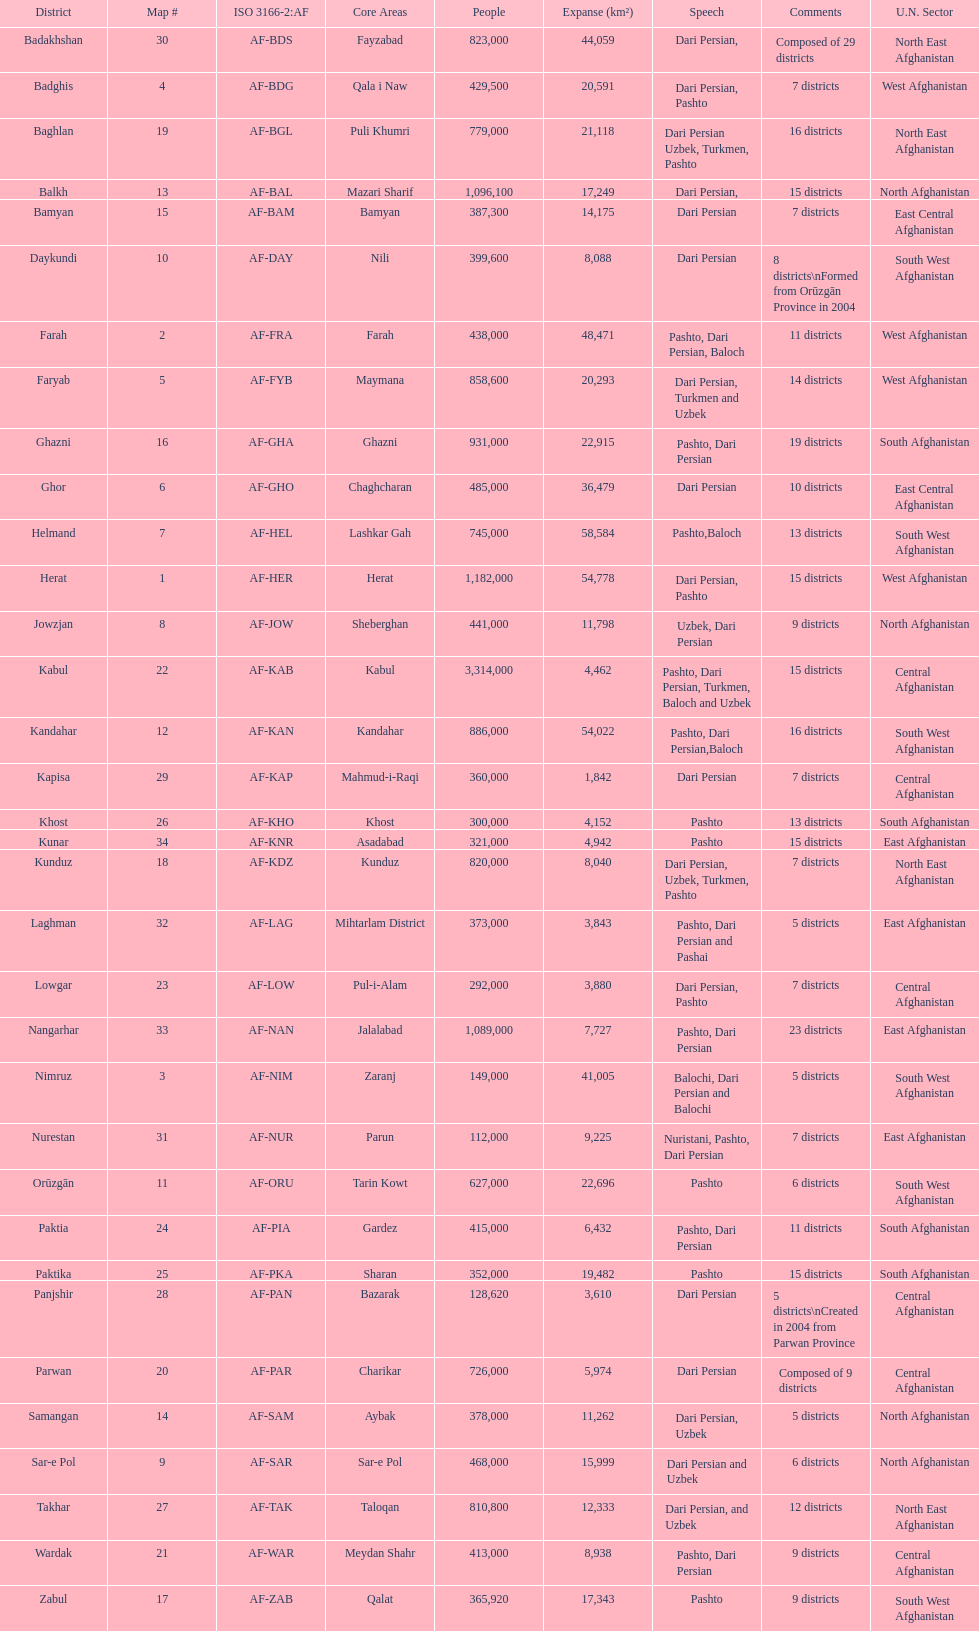How many districts are in the province of kunduz? 7. 